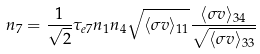<formula> <loc_0><loc_0><loc_500><loc_500>n _ { 7 } = \frac { 1 } { \sqrt { 2 } } \tau _ { e 7 } n _ { 1 } n _ { 4 } \sqrt { \langle \sigma v \rangle _ { 1 1 } } \frac { \langle \sigma v \rangle _ { 3 4 } } { \sqrt { \langle \sigma v \rangle _ { 3 3 } } }</formula> 